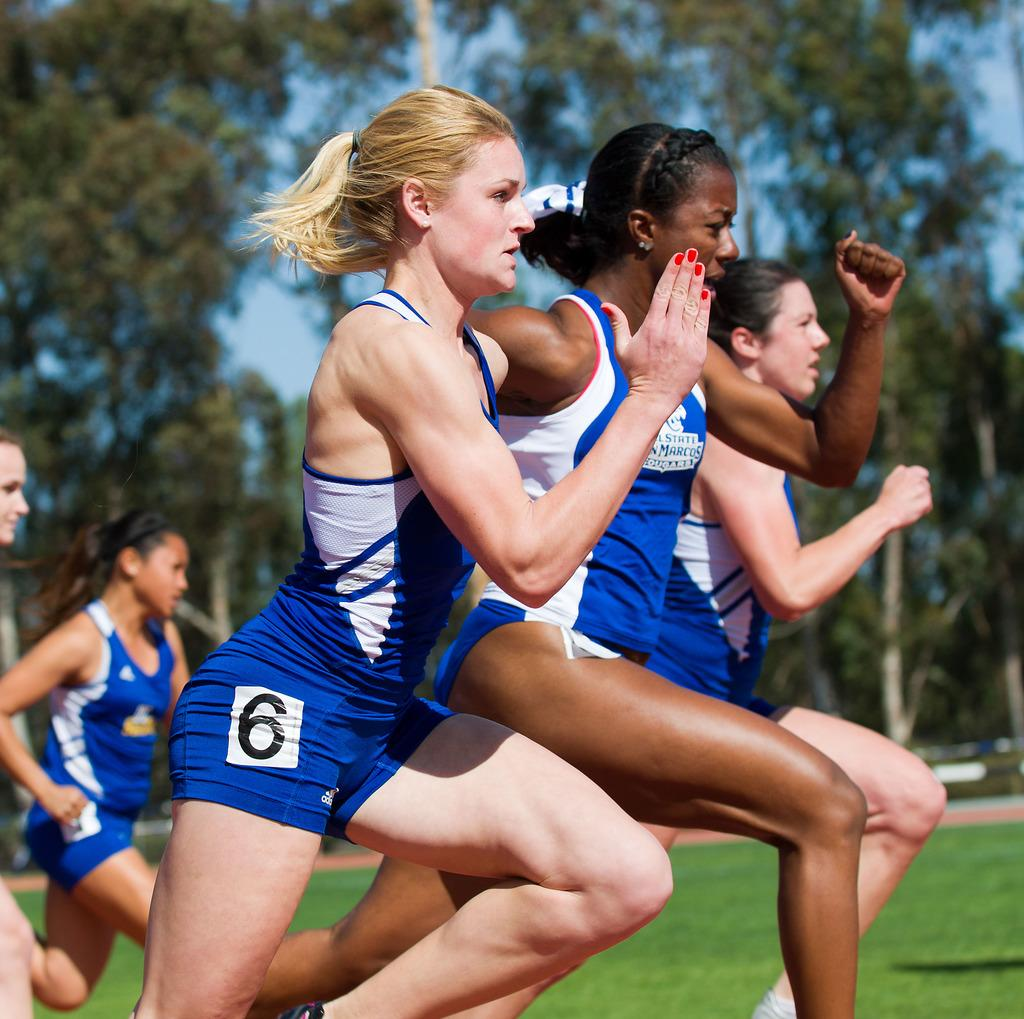<image>
Offer a succinct explanation of the picture presented. Runner with a 6 on her blue shorts is a contender. 